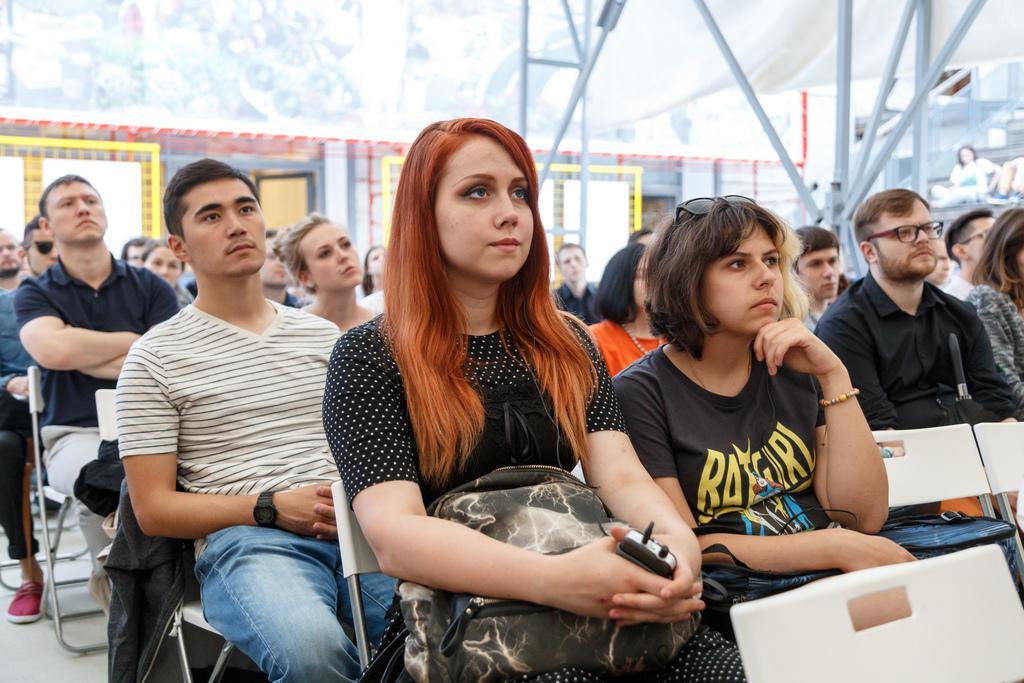Please provide a concise description of this image. In this image we can see people sitting on chairs. In the background of the image there is wall. There are doors. There are rods. 